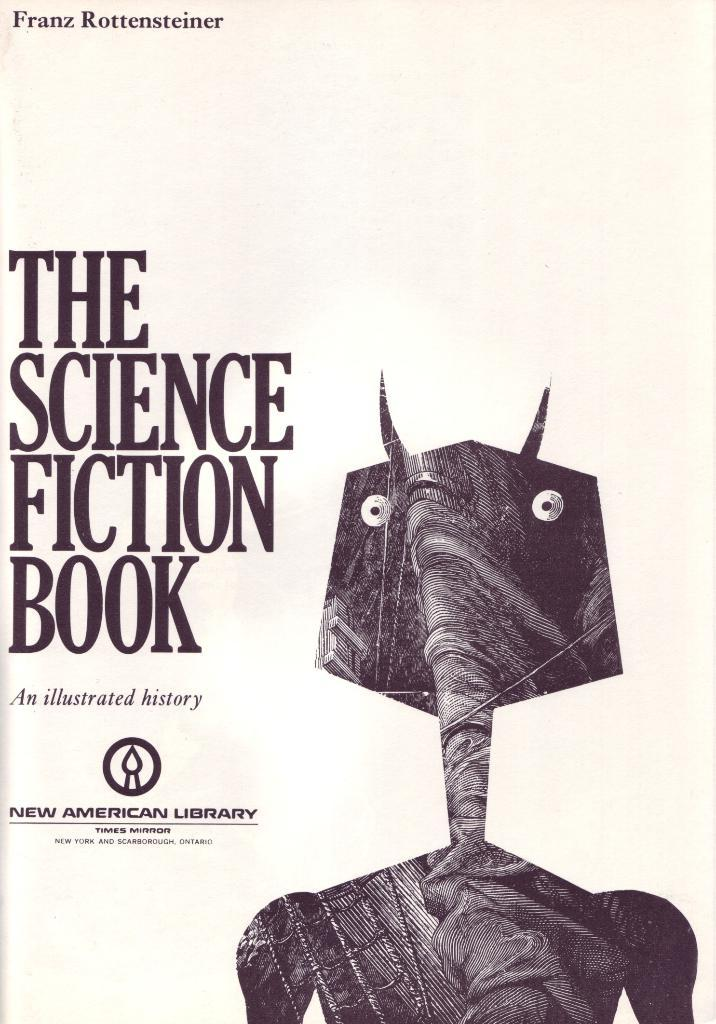What is the main subject of the image? The main subject of the image is a book cover. What type of illustration is featured on the book cover? There is a dragon depicted on the cover. Is there any text on the book cover? Yes, there is text written on the cover page. How often does the owner wash the dragon depicted on the book cover? There is no indication that the dragon is a real, living creature, so it cannot be washed. Additionally, the image is of a book cover, not an actual dragon. 